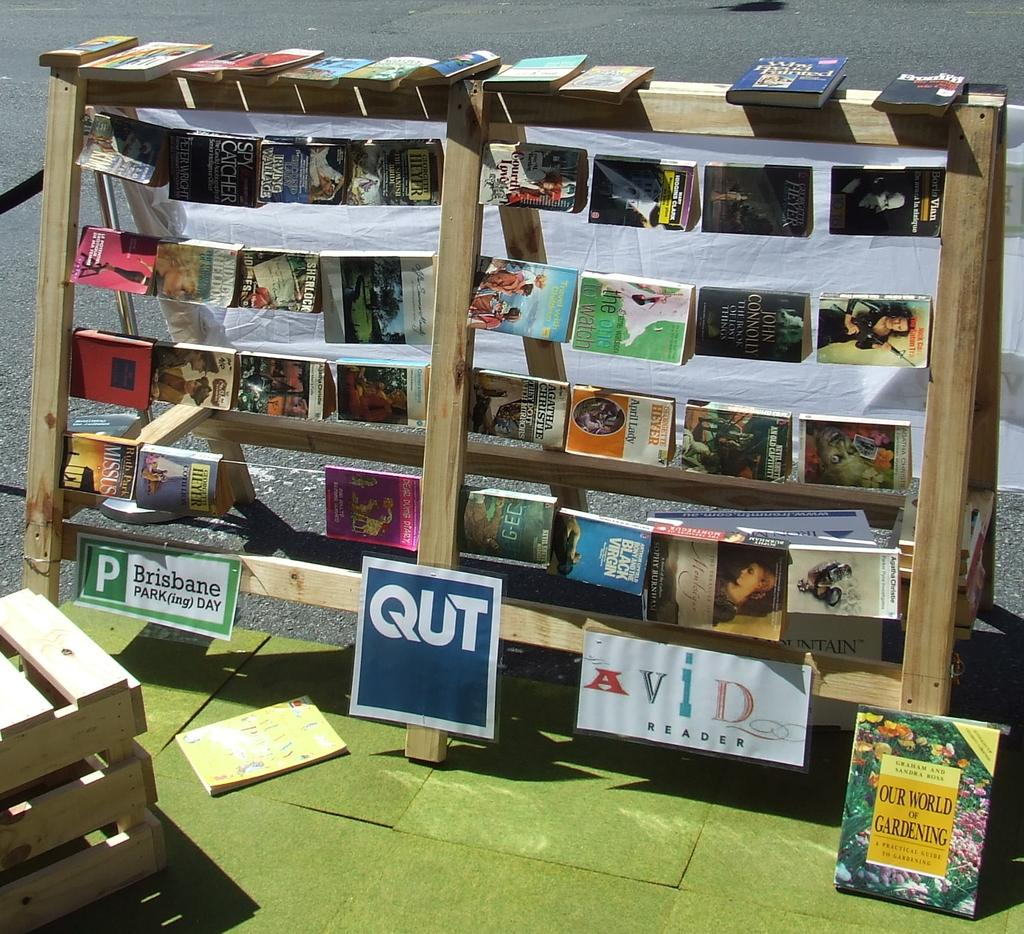Provide a one-sentence caption for the provided image. Bookshelf of books on the outside Avid reader. 